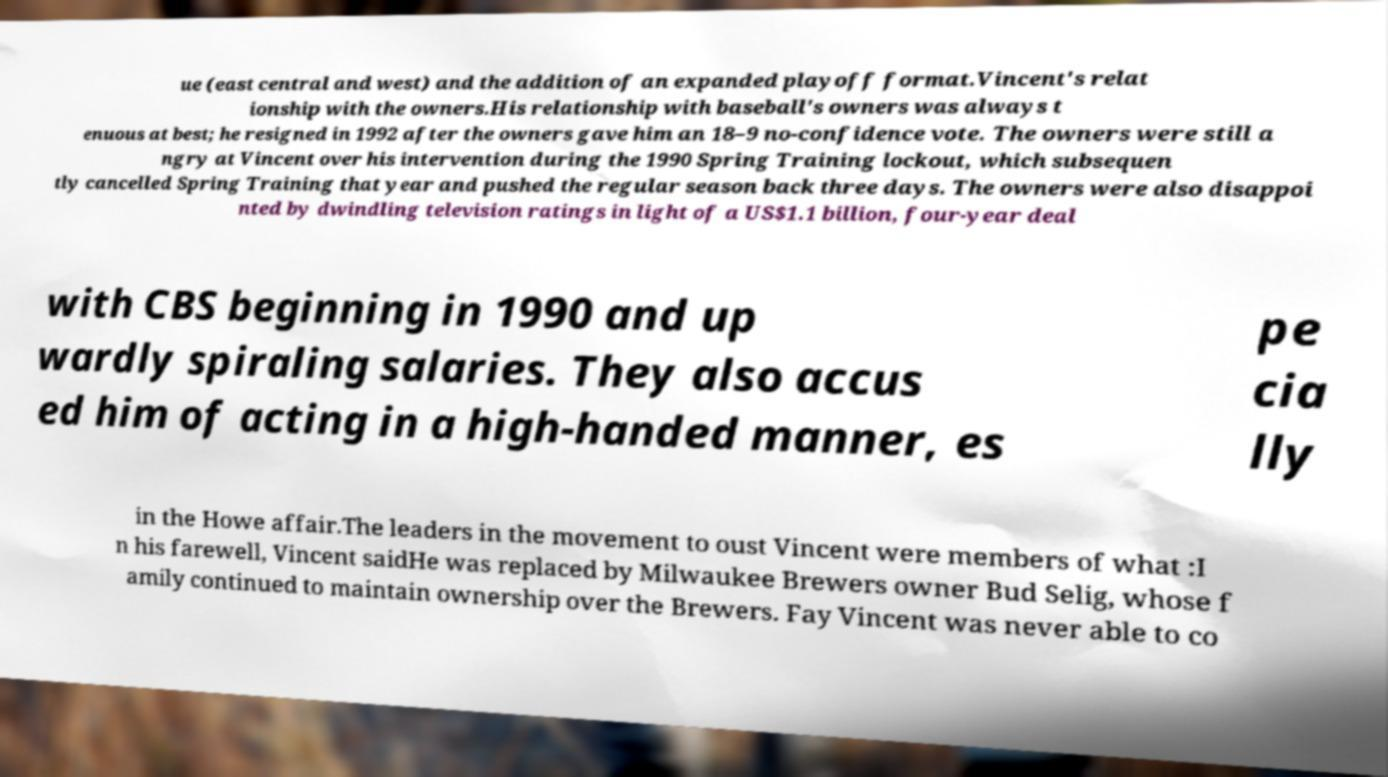Can you accurately transcribe the text from the provided image for me? ue (east central and west) and the addition of an expanded playoff format.Vincent's relat ionship with the owners.His relationship with baseball's owners was always t enuous at best; he resigned in 1992 after the owners gave him an 18–9 no-confidence vote. The owners were still a ngry at Vincent over his intervention during the 1990 Spring Training lockout, which subsequen tly cancelled Spring Training that year and pushed the regular season back three days. The owners were also disappoi nted by dwindling television ratings in light of a US$1.1 billion, four-year deal with CBS beginning in 1990 and up wardly spiraling salaries. They also accus ed him of acting in a high-handed manner, es pe cia lly in the Howe affair.The leaders in the movement to oust Vincent were members of what :I n his farewell, Vincent saidHe was replaced by Milwaukee Brewers owner Bud Selig, whose f amily continued to maintain ownership over the Brewers. Fay Vincent was never able to co 